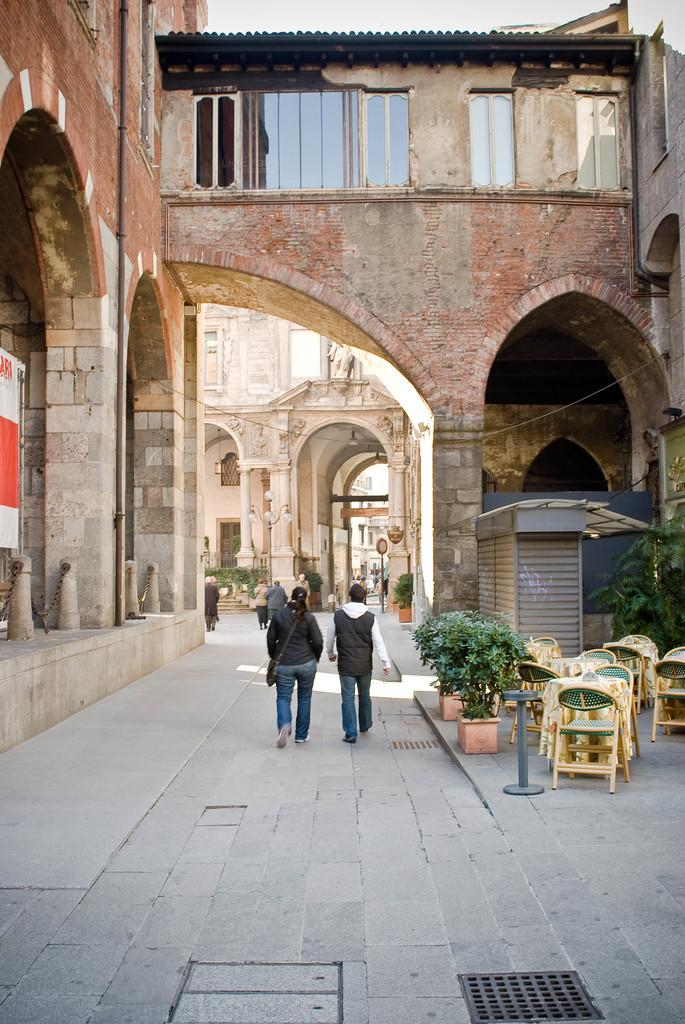How many people are in the image? There is a woman and a man in the image. What are the woman and man doing in the image? The woman and man are walking on a road in the image. What can be seen on the right side of the image? There is a plant on the right side of the image. What type of furniture is present in the image? There are chairs in the image. Can you describe the background of the image? In the background of the image, there is a table, a pole, a wall, and a shed. What type of iron can be seen being used by the woman in the image? There is no iron present in the image, and the woman is not using any iron. What type of trail can be seen in the image? There is no trail visible in the image; it features a woman and a man walking on a road. 